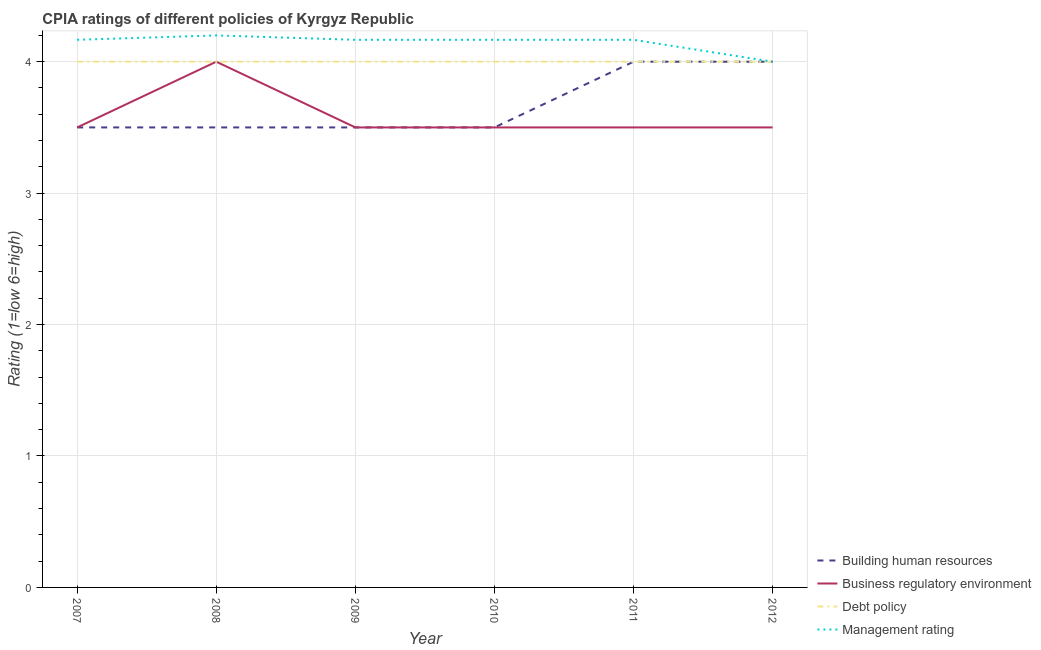Does the line corresponding to cpia rating of business regulatory environment intersect with the line corresponding to cpia rating of building human resources?
Provide a short and direct response. Yes. Is the number of lines equal to the number of legend labels?
Your answer should be very brief. Yes. Across all years, what is the maximum cpia rating of business regulatory environment?
Your answer should be compact. 4. In which year was the cpia rating of business regulatory environment maximum?
Offer a very short reply. 2008. In which year was the cpia rating of management minimum?
Give a very brief answer. 2012. What is the total cpia rating of business regulatory environment in the graph?
Your answer should be very brief. 21.5. What is the difference between the cpia rating of management in 2008 and that in 2011?
Your answer should be compact. 0.03. What is the difference between the cpia rating of management in 2010 and the cpia rating of building human resources in 2008?
Ensure brevity in your answer.  0.67. What is the average cpia rating of management per year?
Offer a very short reply. 4.14. In the year 2007, what is the difference between the cpia rating of building human resources and cpia rating of debt policy?
Keep it short and to the point. -0.5. In how many years, is the cpia rating of management greater than 0.2?
Ensure brevity in your answer.  6. What is the ratio of the cpia rating of management in 2007 to that in 2009?
Your answer should be very brief. 1. Is the cpia rating of debt policy in 2009 less than that in 2012?
Your answer should be very brief. No. Is the difference between the cpia rating of management in 2009 and 2011 greater than the difference between the cpia rating of business regulatory environment in 2009 and 2011?
Your response must be concise. No. What is the difference between the highest and the lowest cpia rating of business regulatory environment?
Ensure brevity in your answer.  0.5. In how many years, is the cpia rating of business regulatory environment greater than the average cpia rating of business regulatory environment taken over all years?
Keep it short and to the point. 1. Is the sum of the cpia rating of debt policy in 2010 and 2011 greater than the maximum cpia rating of business regulatory environment across all years?
Make the answer very short. Yes. Is it the case that in every year, the sum of the cpia rating of building human resources and cpia rating of business regulatory environment is greater than the cpia rating of debt policy?
Your answer should be very brief. Yes. Is the cpia rating of building human resources strictly greater than the cpia rating of debt policy over the years?
Provide a succinct answer. No. How many lines are there?
Your answer should be compact. 4. How many years are there in the graph?
Provide a succinct answer. 6. Are the values on the major ticks of Y-axis written in scientific E-notation?
Your answer should be very brief. No. Does the graph contain grids?
Your answer should be very brief. Yes. Where does the legend appear in the graph?
Make the answer very short. Bottom right. How are the legend labels stacked?
Give a very brief answer. Vertical. What is the title of the graph?
Your answer should be very brief. CPIA ratings of different policies of Kyrgyz Republic. Does "Fish species" appear as one of the legend labels in the graph?
Your answer should be compact. No. What is the label or title of the Y-axis?
Offer a very short reply. Rating (1=low 6=high). What is the Rating (1=low 6=high) in Business regulatory environment in 2007?
Ensure brevity in your answer.  3.5. What is the Rating (1=low 6=high) in Management rating in 2007?
Provide a succinct answer. 4.17. What is the Rating (1=low 6=high) in Building human resources in 2008?
Your answer should be very brief. 3.5. What is the Rating (1=low 6=high) in Business regulatory environment in 2008?
Offer a very short reply. 4. What is the Rating (1=low 6=high) of Building human resources in 2009?
Offer a terse response. 3.5. What is the Rating (1=low 6=high) of Business regulatory environment in 2009?
Provide a short and direct response. 3.5. What is the Rating (1=low 6=high) in Debt policy in 2009?
Ensure brevity in your answer.  4. What is the Rating (1=low 6=high) in Management rating in 2009?
Ensure brevity in your answer.  4.17. What is the Rating (1=low 6=high) of Building human resources in 2010?
Give a very brief answer. 3.5. What is the Rating (1=low 6=high) in Management rating in 2010?
Make the answer very short. 4.17. What is the Rating (1=low 6=high) of Building human resources in 2011?
Give a very brief answer. 4. What is the Rating (1=low 6=high) of Debt policy in 2011?
Provide a succinct answer. 4. What is the Rating (1=low 6=high) in Management rating in 2011?
Keep it short and to the point. 4.17. What is the Rating (1=low 6=high) of Building human resources in 2012?
Your answer should be very brief. 4. What is the Rating (1=low 6=high) in Business regulatory environment in 2012?
Your answer should be compact. 3.5. What is the Rating (1=low 6=high) in Debt policy in 2012?
Provide a succinct answer. 4. Across all years, what is the maximum Rating (1=low 6=high) in Management rating?
Give a very brief answer. 4.2. Across all years, what is the minimum Rating (1=low 6=high) in Business regulatory environment?
Your answer should be very brief. 3.5. What is the total Rating (1=low 6=high) in Business regulatory environment in the graph?
Make the answer very short. 21.5. What is the total Rating (1=low 6=high) of Debt policy in the graph?
Offer a very short reply. 24. What is the total Rating (1=low 6=high) of Management rating in the graph?
Your answer should be compact. 24.87. What is the difference between the Rating (1=low 6=high) of Debt policy in 2007 and that in 2008?
Give a very brief answer. 0. What is the difference between the Rating (1=low 6=high) of Management rating in 2007 and that in 2008?
Offer a terse response. -0.03. What is the difference between the Rating (1=low 6=high) of Building human resources in 2007 and that in 2009?
Your response must be concise. 0. What is the difference between the Rating (1=low 6=high) in Business regulatory environment in 2007 and that in 2009?
Make the answer very short. 0. What is the difference between the Rating (1=low 6=high) of Management rating in 2007 and that in 2009?
Your answer should be very brief. 0. What is the difference between the Rating (1=low 6=high) of Building human resources in 2007 and that in 2010?
Your response must be concise. 0. What is the difference between the Rating (1=low 6=high) of Business regulatory environment in 2007 and that in 2010?
Give a very brief answer. 0. What is the difference between the Rating (1=low 6=high) in Debt policy in 2007 and that in 2011?
Make the answer very short. 0. What is the difference between the Rating (1=low 6=high) in Management rating in 2007 and that in 2011?
Your response must be concise. 0. What is the difference between the Rating (1=low 6=high) of Business regulatory environment in 2008 and that in 2009?
Ensure brevity in your answer.  0.5. What is the difference between the Rating (1=low 6=high) of Debt policy in 2008 and that in 2009?
Offer a terse response. 0. What is the difference between the Rating (1=low 6=high) of Management rating in 2008 and that in 2009?
Your answer should be compact. 0.03. What is the difference between the Rating (1=low 6=high) in Business regulatory environment in 2008 and that in 2010?
Offer a terse response. 0.5. What is the difference between the Rating (1=low 6=high) in Building human resources in 2008 and that in 2011?
Keep it short and to the point. -0.5. What is the difference between the Rating (1=low 6=high) of Business regulatory environment in 2008 and that in 2012?
Offer a very short reply. 0.5. What is the difference between the Rating (1=low 6=high) of Building human resources in 2009 and that in 2010?
Your answer should be very brief. 0. What is the difference between the Rating (1=low 6=high) of Business regulatory environment in 2009 and that in 2010?
Provide a short and direct response. 0. What is the difference between the Rating (1=low 6=high) of Building human resources in 2009 and that in 2011?
Your answer should be compact. -0.5. What is the difference between the Rating (1=low 6=high) in Business regulatory environment in 2009 and that in 2011?
Your response must be concise. 0. What is the difference between the Rating (1=low 6=high) of Debt policy in 2009 and that in 2011?
Your response must be concise. 0. What is the difference between the Rating (1=low 6=high) of Debt policy in 2009 and that in 2012?
Provide a short and direct response. 0. What is the difference between the Rating (1=low 6=high) in Management rating in 2009 and that in 2012?
Ensure brevity in your answer.  0.17. What is the difference between the Rating (1=low 6=high) of Building human resources in 2010 and that in 2011?
Provide a succinct answer. -0.5. What is the difference between the Rating (1=low 6=high) in Business regulatory environment in 2010 and that in 2011?
Your answer should be very brief. 0. What is the difference between the Rating (1=low 6=high) in Debt policy in 2010 and that in 2011?
Offer a very short reply. 0. What is the difference between the Rating (1=low 6=high) in Management rating in 2010 and that in 2011?
Your response must be concise. 0. What is the difference between the Rating (1=low 6=high) in Management rating in 2010 and that in 2012?
Provide a short and direct response. 0.17. What is the difference between the Rating (1=low 6=high) in Debt policy in 2011 and that in 2012?
Give a very brief answer. 0. What is the difference between the Rating (1=low 6=high) of Management rating in 2011 and that in 2012?
Your answer should be compact. 0.17. What is the difference between the Rating (1=low 6=high) of Building human resources in 2007 and the Rating (1=low 6=high) of Debt policy in 2008?
Make the answer very short. -0.5. What is the difference between the Rating (1=low 6=high) in Building human resources in 2007 and the Rating (1=low 6=high) in Management rating in 2008?
Your answer should be compact. -0.7. What is the difference between the Rating (1=low 6=high) of Debt policy in 2007 and the Rating (1=low 6=high) of Management rating in 2008?
Your answer should be compact. -0.2. What is the difference between the Rating (1=low 6=high) of Building human resources in 2007 and the Rating (1=low 6=high) of Debt policy in 2009?
Ensure brevity in your answer.  -0.5. What is the difference between the Rating (1=low 6=high) in Business regulatory environment in 2007 and the Rating (1=low 6=high) in Management rating in 2009?
Your answer should be very brief. -0.67. What is the difference between the Rating (1=low 6=high) of Debt policy in 2007 and the Rating (1=low 6=high) of Management rating in 2009?
Keep it short and to the point. -0.17. What is the difference between the Rating (1=low 6=high) of Building human resources in 2007 and the Rating (1=low 6=high) of Debt policy in 2010?
Ensure brevity in your answer.  -0.5. What is the difference between the Rating (1=low 6=high) of Business regulatory environment in 2007 and the Rating (1=low 6=high) of Debt policy in 2010?
Your answer should be compact. -0.5. What is the difference between the Rating (1=low 6=high) in Debt policy in 2007 and the Rating (1=low 6=high) in Management rating in 2010?
Give a very brief answer. -0.17. What is the difference between the Rating (1=low 6=high) in Building human resources in 2007 and the Rating (1=low 6=high) in Business regulatory environment in 2011?
Your answer should be very brief. 0. What is the difference between the Rating (1=low 6=high) in Business regulatory environment in 2007 and the Rating (1=low 6=high) in Debt policy in 2011?
Offer a very short reply. -0.5. What is the difference between the Rating (1=low 6=high) in Debt policy in 2007 and the Rating (1=low 6=high) in Management rating in 2011?
Ensure brevity in your answer.  -0.17. What is the difference between the Rating (1=low 6=high) of Business regulatory environment in 2007 and the Rating (1=low 6=high) of Debt policy in 2012?
Offer a very short reply. -0.5. What is the difference between the Rating (1=low 6=high) in Business regulatory environment in 2008 and the Rating (1=low 6=high) in Management rating in 2009?
Provide a succinct answer. -0.17. What is the difference between the Rating (1=low 6=high) of Building human resources in 2008 and the Rating (1=low 6=high) of Business regulatory environment in 2010?
Your answer should be compact. 0. What is the difference between the Rating (1=low 6=high) in Building human resources in 2008 and the Rating (1=low 6=high) in Management rating in 2010?
Your answer should be compact. -0.67. What is the difference between the Rating (1=low 6=high) of Business regulatory environment in 2008 and the Rating (1=low 6=high) of Debt policy in 2010?
Give a very brief answer. 0. What is the difference between the Rating (1=low 6=high) in Business regulatory environment in 2008 and the Rating (1=low 6=high) in Management rating in 2010?
Offer a very short reply. -0.17. What is the difference between the Rating (1=low 6=high) in Debt policy in 2008 and the Rating (1=low 6=high) in Management rating in 2010?
Offer a terse response. -0.17. What is the difference between the Rating (1=low 6=high) in Business regulatory environment in 2008 and the Rating (1=low 6=high) in Debt policy in 2011?
Provide a short and direct response. 0. What is the difference between the Rating (1=low 6=high) in Debt policy in 2008 and the Rating (1=low 6=high) in Management rating in 2011?
Keep it short and to the point. -0.17. What is the difference between the Rating (1=low 6=high) of Building human resources in 2008 and the Rating (1=low 6=high) of Business regulatory environment in 2012?
Offer a terse response. 0. What is the difference between the Rating (1=low 6=high) in Building human resources in 2008 and the Rating (1=low 6=high) in Debt policy in 2012?
Your response must be concise. -0.5. What is the difference between the Rating (1=low 6=high) in Building human resources in 2008 and the Rating (1=low 6=high) in Management rating in 2012?
Give a very brief answer. -0.5. What is the difference between the Rating (1=low 6=high) of Business regulatory environment in 2008 and the Rating (1=low 6=high) of Debt policy in 2012?
Provide a succinct answer. 0. What is the difference between the Rating (1=low 6=high) in Business regulatory environment in 2008 and the Rating (1=low 6=high) in Management rating in 2012?
Keep it short and to the point. 0. What is the difference between the Rating (1=low 6=high) of Debt policy in 2008 and the Rating (1=low 6=high) of Management rating in 2012?
Your answer should be compact. 0. What is the difference between the Rating (1=low 6=high) in Building human resources in 2009 and the Rating (1=low 6=high) in Business regulatory environment in 2010?
Your response must be concise. 0. What is the difference between the Rating (1=low 6=high) in Building human resources in 2009 and the Rating (1=low 6=high) in Debt policy in 2010?
Offer a very short reply. -0.5. What is the difference between the Rating (1=low 6=high) in Building human resources in 2009 and the Rating (1=low 6=high) in Management rating in 2010?
Give a very brief answer. -0.67. What is the difference between the Rating (1=low 6=high) in Debt policy in 2009 and the Rating (1=low 6=high) in Management rating in 2010?
Your response must be concise. -0.17. What is the difference between the Rating (1=low 6=high) in Building human resources in 2009 and the Rating (1=low 6=high) in Debt policy in 2011?
Provide a succinct answer. -0.5. What is the difference between the Rating (1=low 6=high) of Debt policy in 2009 and the Rating (1=low 6=high) of Management rating in 2011?
Your answer should be compact. -0.17. What is the difference between the Rating (1=low 6=high) of Building human resources in 2009 and the Rating (1=low 6=high) of Business regulatory environment in 2012?
Offer a very short reply. 0. What is the difference between the Rating (1=low 6=high) of Building human resources in 2009 and the Rating (1=low 6=high) of Management rating in 2012?
Make the answer very short. -0.5. What is the difference between the Rating (1=low 6=high) of Business regulatory environment in 2009 and the Rating (1=low 6=high) of Debt policy in 2012?
Ensure brevity in your answer.  -0.5. What is the difference between the Rating (1=low 6=high) of Building human resources in 2010 and the Rating (1=low 6=high) of Business regulatory environment in 2011?
Your answer should be very brief. 0. What is the difference between the Rating (1=low 6=high) in Debt policy in 2010 and the Rating (1=low 6=high) in Management rating in 2011?
Ensure brevity in your answer.  -0.17. What is the difference between the Rating (1=low 6=high) in Building human resources in 2010 and the Rating (1=low 6=high) in Business regulatory environment in 2012?
Your answer should be very brief. 0. What is the difference between the Rating (1=low 6=high) of Building human resources in 2010 and the Rating (1=low 6=high) of Debt policy in 2012?
Your answer should be compact. -0.5. What is the difference between the Rating (1=low 6=high) of Building human resources in 2011 and the Rating (1=low 6=high) of Debt policy in 2012?
Provide a short and direct response. 0. What is the average Rating (1=low 6=high) of Building human resources per year?
Ensure brevity in your answer.  3.67. What is the average Rating (1=low 6=high) in Business regulatory environment per year?
Offer a terse response. 3.58. What is the average Rating (1=low 6=high) in Management rating per year?
Provide a succinct answer. 4.14. In the year 2007, what is the difference between the Rating (1=low 6=high) in Building human resources and Rating (1=low 6=high) in Business regulatory environment?
Your answer should be very brief. 0. In the year 2007, what is the difference between the Rating (1=low 6=high) in Building human resources and Rating (1=low 6=high) in Debt policy?
Ensure brevity in your answer.  -0.5. In the year 2007, what is the difference between the Rating (1=low 6=high) of Business regulatory environment and Rating (1=low 6=high) of Debt policy?
Your answer should be very brief. -0.5. In the year 2007, what is the difference between the Rating (1=low 6=high) of Debt policy and Rating (1=low 6=high) of Management rating?
Offer a very short reply. -0.17. In the year 2008, what is the difference between the Rating (1=low 6=high) in Building human resources and Rating (1=low 6=high) in Business regulatory environment?
Your answer should be compact. -0.5. In the year 2008, what is the difference between the Rating (1=low 6=high) in Building human resources and Rating (1=low 6=high) in Debt policy?
Keep it short and to the point. -0.5. In the year 2008, what is the difference between the Rating (1=low 6=high) of Debt policy and Rating (1=low 6=high) of Management rating?
Make the answer very short. -0.2. In the year 2009, what is the difference between the Rating (1=low 6=high) in Building human resources and Rating (1=low 6=high) in Business regulatory environment?
Make the answer very short. 0. In the year 2009, what is the difference between the Rating (1=low 6=high) in Business regulatory environment and Rating (1=low 6=high) in Debt policy?
Provide a succinct answer. -0.5. In the year 2009, what is the difference between the Rating (1=low 6=high) in Business regulatory environment and Rating (1=low 6=high) in Management rating?
Offer a very short reply. -0.67. In the year 2009, what is the difference between the Rating (1=low 6=high) in Debt policy and Rating (1=low 6=high) in Management rating?
Your answer should be compact. -0.17. In the year 2010, what is the difference between the Rating (1=low 6=high) of Business regulatory environment and Rating (1=low 6=high) of Debt policy?
Offer a very short reply. -0.5. In the year 2010, what is the difference between the Rating (1=low 6=high) of Business regulatory environment and Rating (1=low 6=high) of Management rating?
Keep it short and to the point. -0.67. In the year 2011, what is the difference between the Rating (1=low 6=high) in Building human resources and Rating (1=low 6=high) in Business regulatory environment?
Keep it short and to the point. 0.5. In the year 2011, what is the difference between the Rating (1=low 6=high) of Building human resources and Rating (1=low 6=high) of Debt policy?
Your answer should be compact. 0. In the year 2011, what is the difference between the Rating (1=low 6=high) in Business regulatory environment and Rating (1=low 6=high) in Management rating?
Offer a very short reply. -0.67. In the year 2011, what is the difference between the Rating (1=low 6=high) in Debt policy and Rating (1=low 6=high) in Management rating?
Your answer should be very brief. -0.17. In the year 2012, what is the difference between the Rating (1=low 6=high) in Building human resources and Rating (1=low 6=high) in Debt policy?
Keep it short and to the point. 0. In the year 2012, what is the difference between the Rating (1=low 6=high) in Building human resources and Rating (1=low 6=high) in Management rating?
Offer a very short reply. 0. In the year 2012, what is the difference between the Rating (1=low 6=high) in Business regulatory environment and Rating (1=low 6=high) in Management rating?
Keep it short and to the point. -0.5. In the year 2012, what is the difference between the Rating (1=low 6=high) in Debt policy and Rating (1=low 6=high) in Management rating?
Provide a succinct answer. 0. What is the ratio of the Rating (1=low 6=high) of Building human resources in 2007 to that in 2008?
Offer a very short reply. 1. What is the ratio of the Rating (1=low 6=high) of Debt policy in 2007 to that in 2008?
Give a very brief answer. 1. What is the ratio of the Rating (1=low 6=high) in Management rating in 2007 to that in 2008?
Offer a very short reply. 0.99. What is the ratio of the Rating (1=low 6=high) of Building human resources in 2007 to that in 2009?
Provide a short and direct response. 1. What is the ratio of the Rating (1=low 6=high) in Business regulatory environment in 2007 to that in 2009?
Make the answer very short. 1. What is the ratio of the Rating (1=low 6=high) of Building human resources in 2007 to that in 2010?
Your response must be concise. 1. What is the ratio of the Rating (1=low 6=high) of Business regulatory environment in 2007 to that in 2010?
Offer a very short reply. 1. What is the ratio of the Rating (1=low 6=high) of Debt policy in 2007 to that in 2010?
Your response must be concise. 1. What is the ratio of the Rating (1=low 6=high) in Building human resources in 2007 to that in 2011?
Offer a terse response. 0.88. What is the ratio of the Rating (1=low 6=high) of Debt policy in 2007 to that in 2011?
Make the answer very short. 1. What is the ratio of the Rating (1=low 6=high) in Debt policy in 2007 to that in 2012?
Keep it short and to the point. 1. What is the ratio of the Rating (1=low 6=high) of Management rating in 2007 to that in 2012?
Provide a succinct answer. 1.04. What is the ratio of the Rating (1=low 6=high) in Building human resources in 2008 to that in 2009?
Offer a very short reply. 1. What is the ratio of the Rating (1=low 6=high) in Business regulatory environment in 2008 to that in 2009?
Provide a succinct answer. 1.14. What is the ratio of the Rating (1=low 6=high) in Debt policy in 2008 to that in 2009?
Give a very brief answer. 1. What is the ratio of the Rating (1=low 6=high) of Management rating in 2008 to that in 2010?
Ensure brevity in your answer.  1.01. What is the ratio of the Rating (1=low 6=high) of Building human resources in 2008 to that in 2011?
Give a very brief answer. 0.88. What is the ratio of the Rating (1=low 6=high) in Management rating in 2008 to that in 2011?
Provide a succinct answer. 1.01. What is the ratio of the Rating (1=low 6=high) of Building human resources in 2008 to that in 2012?
Provide a short and direct response. 0.88. What is the ratio of the Rating (1=low 6=high) of Business regulatory environment in 2008 to that in 2012?
Make the answer very short. 1.14. What is the ratio of the Rating (1=low 6=high) of Building human resources in 2009 to that in 2010?
Offer a very short reply. 1. What is the ratio of the Rating (1=low 6=high) in Debt policy in 2009 to that in 2010?
Your answer should be very brief. 1. What is the ratio of the Rating (1=low 6=high) of Building human resources in 2009 to that in 2011?
Your answer should be very brief. 0.88. What is the ratio of the Rating (1=low 6=high) of Business regulatory environment in 2009 to that in 2011?
Keep it short and to the point. 1. What is the ratio of the Rating (1=low 6=high) in Management rating in 2009 to that in 2011?
Provide a short and direct response. 1. What is the ratio of the Rating (1=low 6=high) in Building human resources in 2009 to that in 2012?
Your response must be concise. 0.88. What is the ratio of the Rating (1=low 6=high) of Business regulatory environment in 2009 to that in 2012?
Provide a succinct answer. 1. What is the ratio of the Rating (1=low 6=high) of Debt policy in 2009 to that in 2012?
Keep it short and to the point. 1. What is the ratio of the Rating (1=low 6=high) in Management rating in 2009 to that in 2012?
Ensure brevity in your answer.  1.04. What is the ratio of the Rating (1=low 6=high) of Building human resources in 2010 to that in 2011?
Provide a succinct answer. 0.88. What is the ratio of the Rating (1=low 6=high) of Business regulatory environment in 2010 to that in 2011?
Give a very brief answer. 1. What is the ratio of the Rating (1=low 6=high) in Debt policy in 2010 to that in 2011?
Give a very brief answer. 1. What is the ratio of the Rating (1=low 6=high) of Management rating in 2010 to that in 2011?
Provide a succinct answer. 1. What is the ratio of the Rating (1=low 6=high) in Business regulatory environment in 2010 to that in 2012?
Keep it short and to the point. 1. What is the ratio of the Rating (1=low 6=high) in Management rating in 2010 to that in 2012?
Provide a short and direct response. 1.04. What is the ratio of the Rating (1=low 6=high) of Building human resources in 2011 to that in 2012?
Provide a short and direct response. 1. What is the ratio of the Rating (1=low 6=high) of Business regulatory environment in 2011 to that in 2012?
Give a very brief answer. 1. What is the ratio of the Rating (1=low 6=high) in Debt policy in 2011 to that in 2012?
Your response must be concise. 1. What is the ratio of the Rating (1=low 6=high) of Management rating in 2011 to that in 2012?
Ensure brevity in your answer.  1.04. What is the difference between the highest and the second highest Rating (1=low 6=high) in Building human resources?
Your answer should be compact. 0. What is the difference between the highest and the second highest Rating (1=low 6=high) in Debt policy?
Make the answer very short. 0. What is the difference between the highest and the second highest Rating (1=low 6=high) in Management rating?
Provide a short and direct response. 0.03. What is the difference between the highest and the lowest Rating (1=low 6=high) in Debt policy?
Your answer should be very brief. 0. 